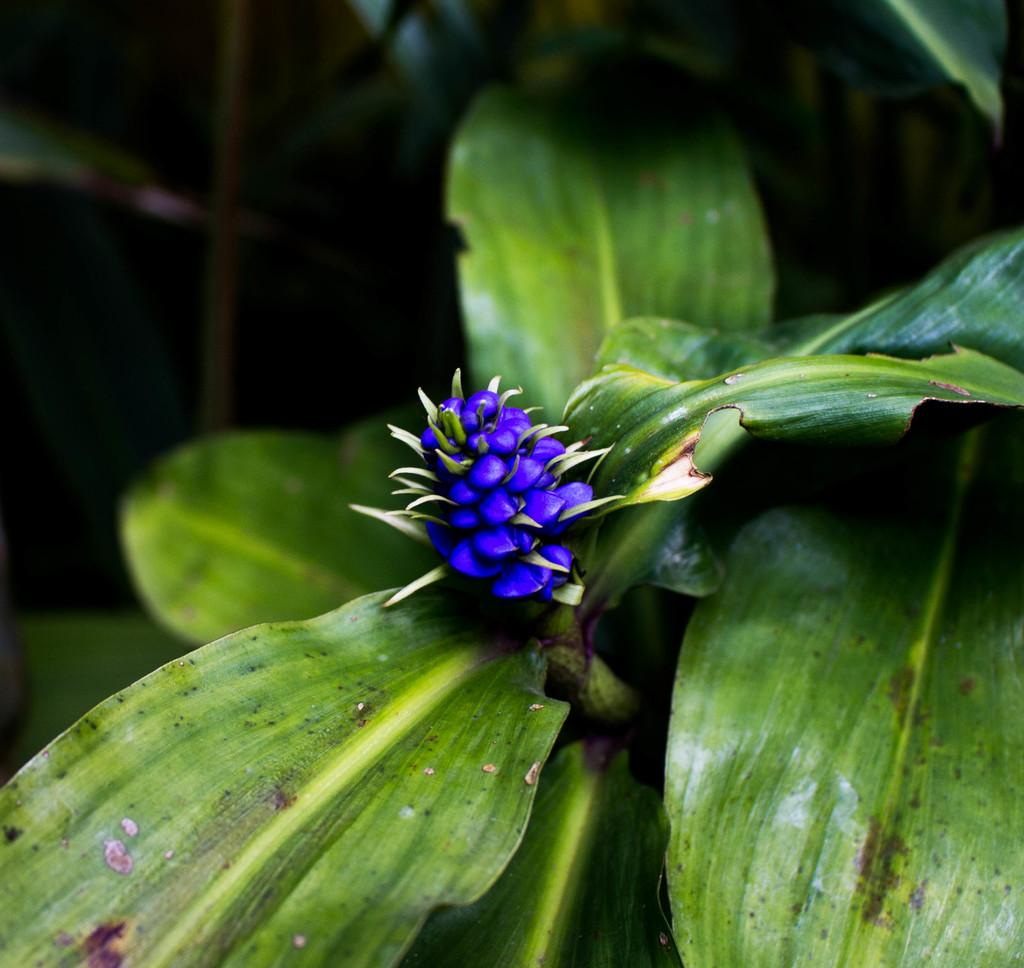What is the main subject of the image? There is a flower in the image. What color is the flower? The flower is purple. What else can be seen in the background of the image? There are leaves in the background of the image. What color are the leaves? The leaves are green. How much oil is being used to maintain the flower in the image? There is no mention of oil being used to maintain the flower in the image, and therefore no such information can be provided. 